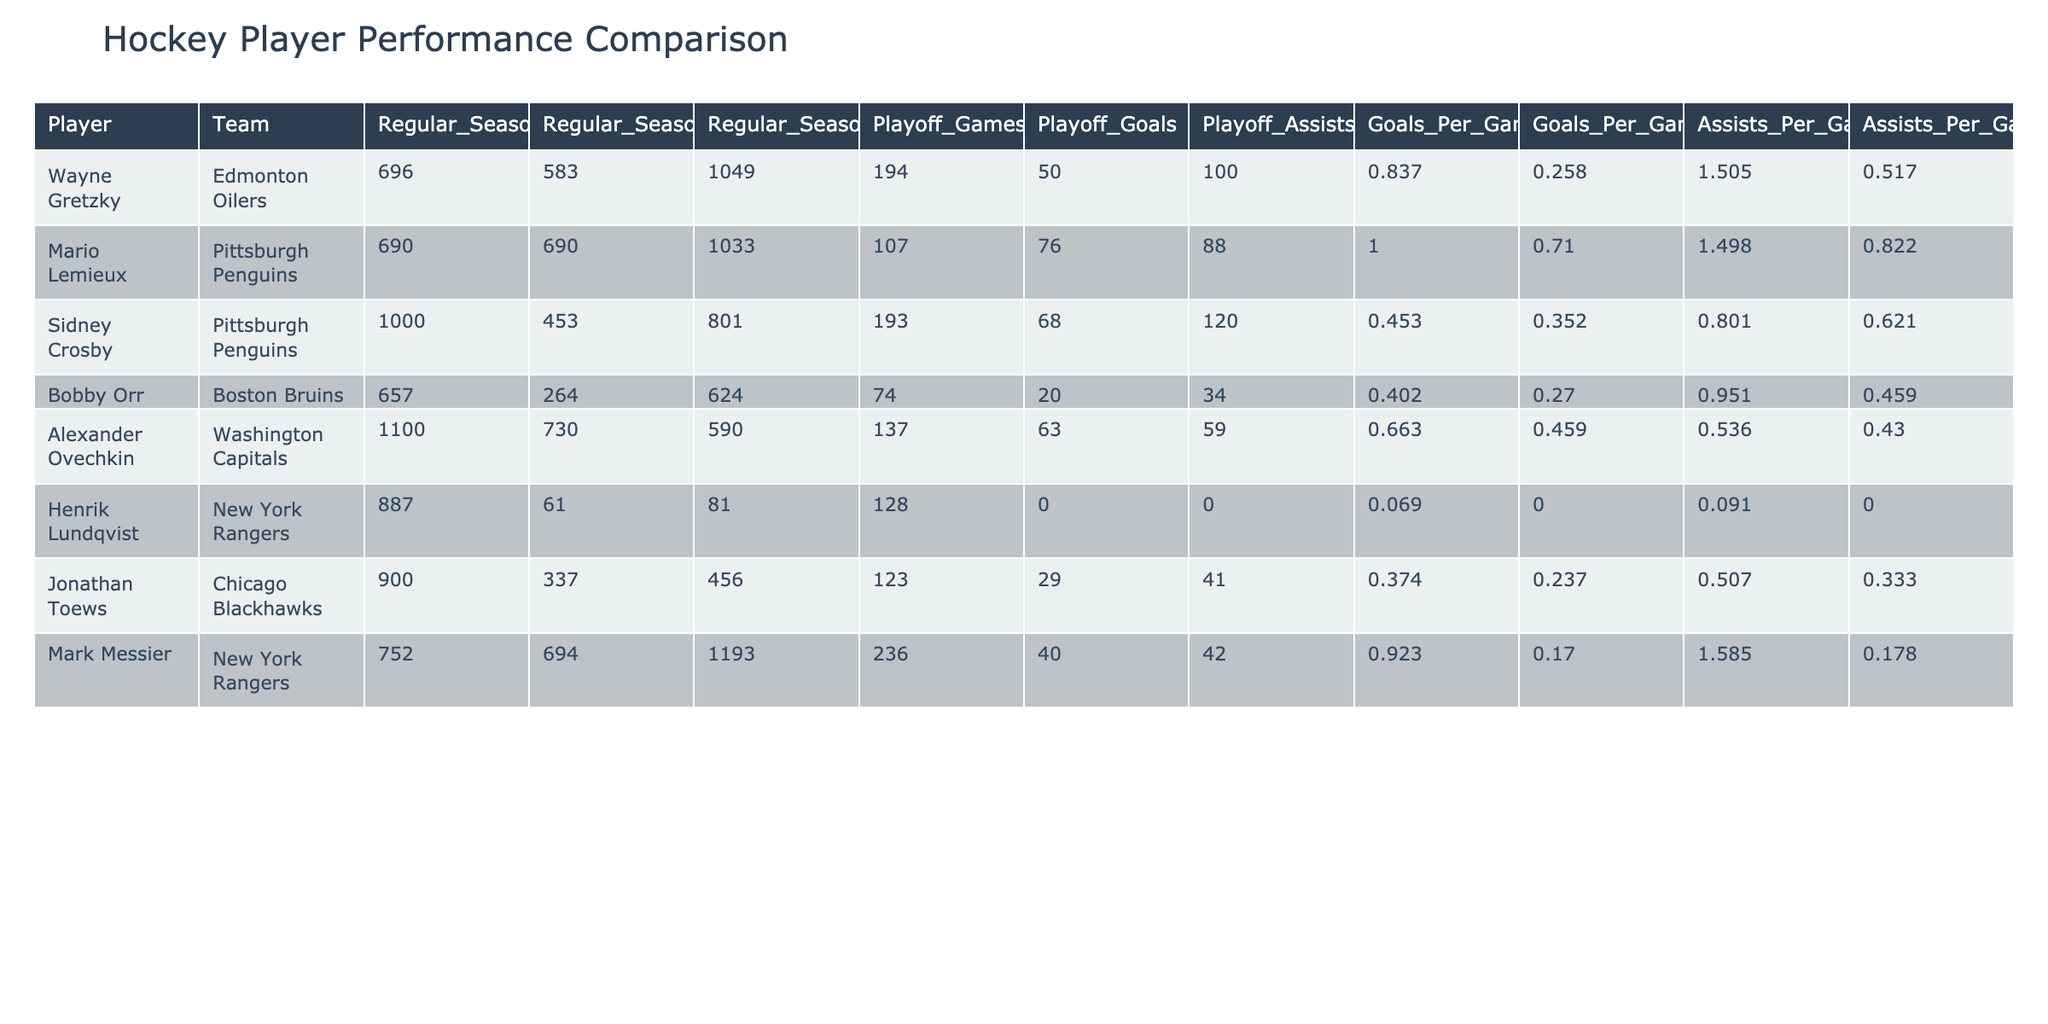What player has the highest goals per game in the regular season? By looking at the "Goals_Per_Game_Regular_Season" column, we see that Mario Lemieux has a value of 1.000, which is the highest among all players listed.
Answer: Mario Lemieux What is Sidney Crosby's total points in the playoffs? To find Sidney Crosby's total points in the playoffs, we add his playoff goals (68) to his playoff assists (120): 68 + 120 = 188 points.
Answer: 188 Which player has a higher assists per game in the regular season than in the playoffs? Comparing the "Assists_Per_Game_Regular_Season" and "Assists_Per_Game_Playoffs" columns, we see that Mark Messier has a value of 1.585 in the regular season, which is higher than his playoff value of 0.178.
Answer: Yes How many playoff games did Wayne Gretzky play compared to Alexander Ovechkin? From the "Playoff_Games" column, Wayne Gretzky played 194 playoff games, while Alexander Ovechkin played 137 playoff games. The difference is 194 - 137 = 57 games.
Answer: 57 games Who scored the most goals in the regular season among the listed players? Looking at the "Regular_Season_Goals" column, Mario Lemieux scored 690 goals, which is the highest total compared to other players.
Answer: Mario Lemieux What is the percentage difference in goals per game between regular season and playoffs for Jonathan Toews? First, identify his regular season goals per game (0.374) and playoff goals per game (0.237). The difference is 0.374 - 0.237 = 0.137. To find the percentage difference: (0.137 / 0.374) * 100 ≈ 36.6%.
Answer: Approximately 36.6% Did Henrik Lundqvist score any goals in the playoffs? According to the "Playoff_Goals" column, Henrik Lundqvist has a value of 0, indicating he did not score any goals in the playoffs.
Answer: No Which player had the highest assist total in the regular season? Analyzing the "Regular_Season_Assists" column, Mark Messier has the highest total of 1193 assists.
Answer: Mark Messier 